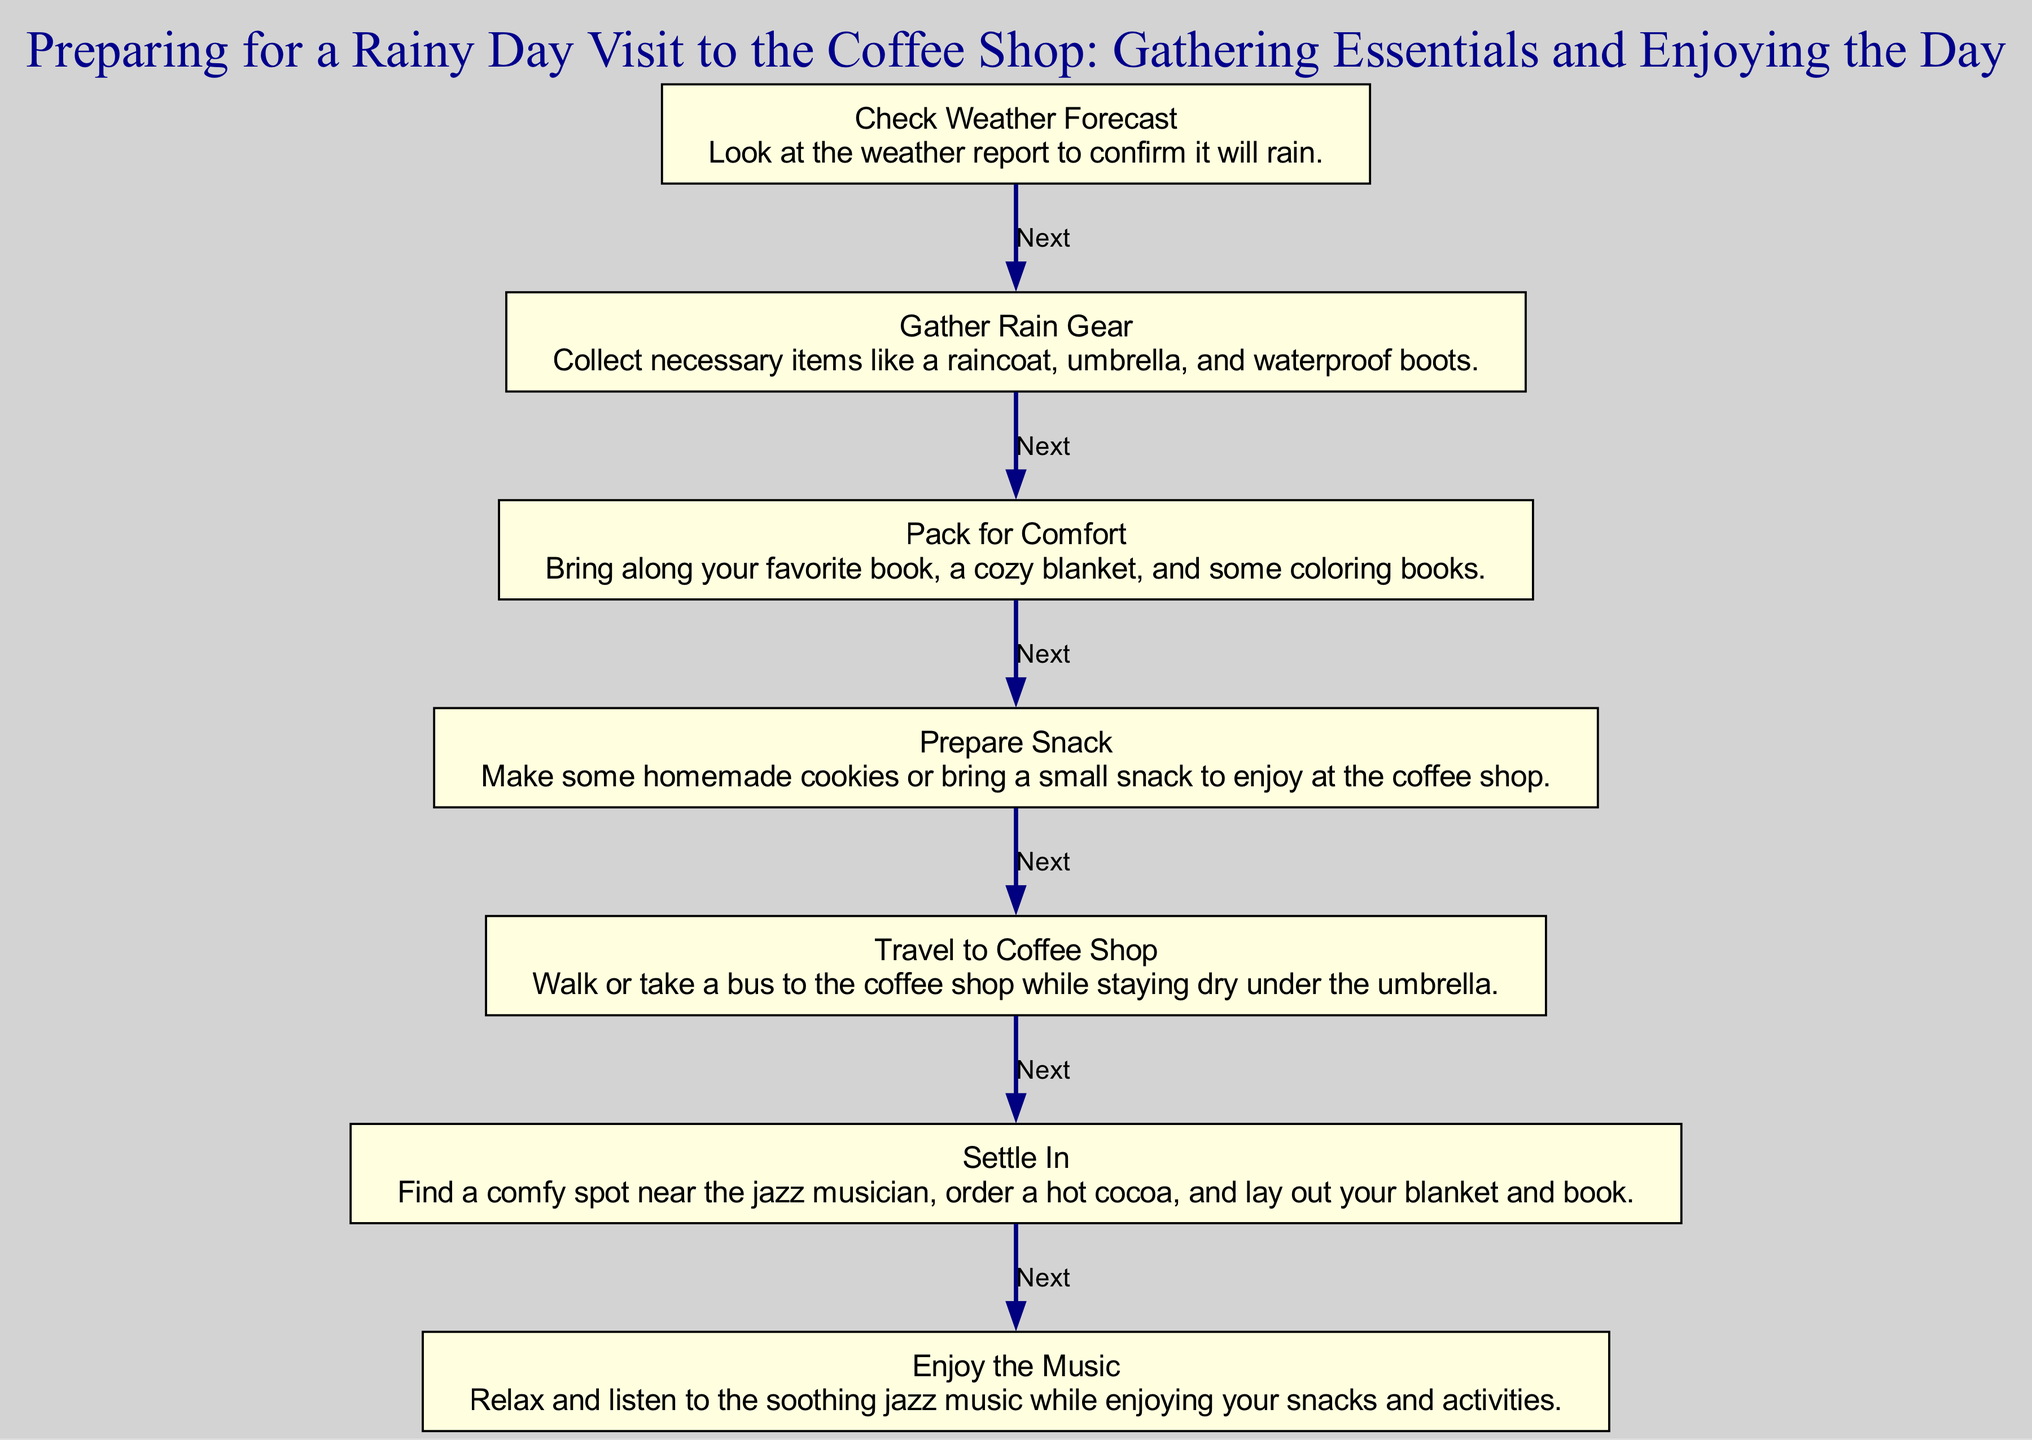What is the first step in preparing for a rainy day visit? The first step in the diagram is labeled "Check Weather Forecast." It is located at the top of the flow chart and sets the intention for the rest of the steps based on the weather report.
Answer: Check Weather Forecast How many steps are there in total? The diagram outlines a total of seven steps, which are linked sequentially from the beginning to the end of the process. You can count each step listed in the flow to confirm this number.
Answer: Seven What do you pack for comfort? According to the flow chart, when you reach the "Pack for Comfort" step, it mentions bringing along a favorite book, a cozy blanket, and some coloring books. This is highlighted in the description for that step.
Answer: Favorite book, cozy blanket, coloring books What follows after preparing a snack? The step that follows "Prepare Snack" is "Travel to Coffee Shop." This detail is indicated by the connection or edge leading from one node to the next in the sequence.
Answer: Travel to Coffee Shop What item do you order after settling in? After reaching the "Settle In" step, the diagram specifies that you order a hot cocoa. This is mentioned directly in the description for that step as part of what you do when you settle in at the coffee shop.
Answer: Hot cocoa How do you get to the coffee shop? The "Travel to Coffee Shop" step describes that you either walk or take a bus while staying dry under the umbrella. This detail explains the means of travel as part of the preparation for your visit.
Answer: Walk or take a bus What is the final activity mentioned in the diagram? The final activity in the flow chart is "Enjoy the Music," which is the last step where you relax and listen to jazz music while enjoying snacks. This marks the conclusion of the sequence.
Answer: Enjoy the Music 